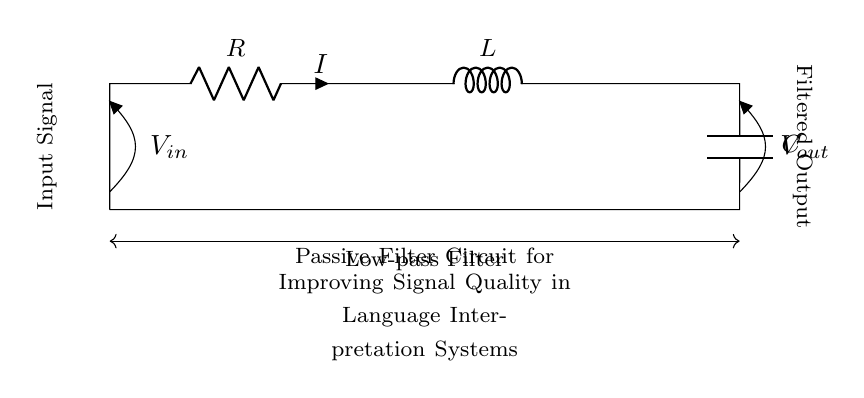What are the components used in this circuit? The circuit diagram contains three main components: a resistor, an inductor, and a capacitor. These components are indicated by their symbols and labeled as R, L, and C.
Answer: Resistor, Inductor, Capacitor What type of filter is shown in this circuit? The diagram specifically indicates a low-pass filter, which allows low-frequency signals to pass while attenuating high-frequency signals. This is noted by the labeling in the circuit description.
Answer: Low-pass Filter What is the function of the resistor in the circuit? The resistor provides resistance to the current flow, which helps to define the cutoff frequency of the low-pass filter and limits the overall current in the circuit. This function is important for controlling the signal attenuation.
Answer: Current limiting What is the relationship between input and output voltage in this circuit? The output voltage is typically less than the input voltage due to the passive components. The relationship can be expressed as the output voltage depending on the component values and the frequency of the input signal, but it is primarily defined by the filtering effect of the circuit.
Answer: Voltage drop How does the inductor affect the signal quality in this filter? The inductor opposes changes in current, which helps maintain a smoother current flow through the circuit, reducing high-frequency noise and improving the signal quality of the output. This resistance to rapid changes is a key property of inductors in filters.
Answer: Maintains current smoothing What happens to high-frequency signals in this circuit? High-frequency signals are attenuated, meaning their amplitudes are reduced as they pass through the circuit. The specific design of the low-pass filter ensures that these signals do not contribute significantly to the output.
Answer: Attenuated How does the capacitor behave in this filter? The capacitor allows AC signals to pass while blocking DC signals, contributing to the overall filtering action of the circuit. Specifically, it helps short out high-frequency components, which further clarifies low-frequency signals at the output, fulfilling the low-pass function.
Answer: Blocks DC, allows AC 